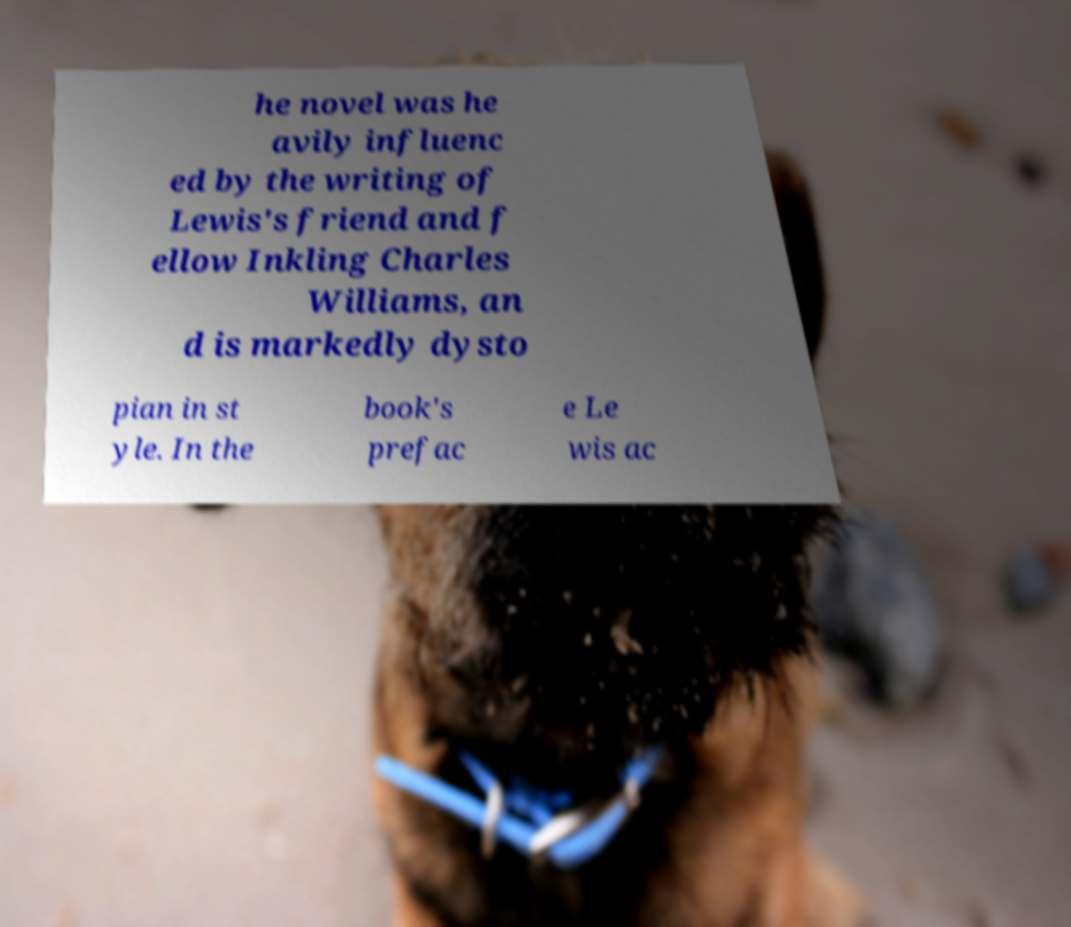What messages or text are displayed in this image? I need them in a readable, typed format. he novel was he avily influenc ed by the writing of Lewis's friend and f ellow Inkling Charles Williams, an d is markedly dysto pian in st yle. In the book's prefac e Le wis ac 